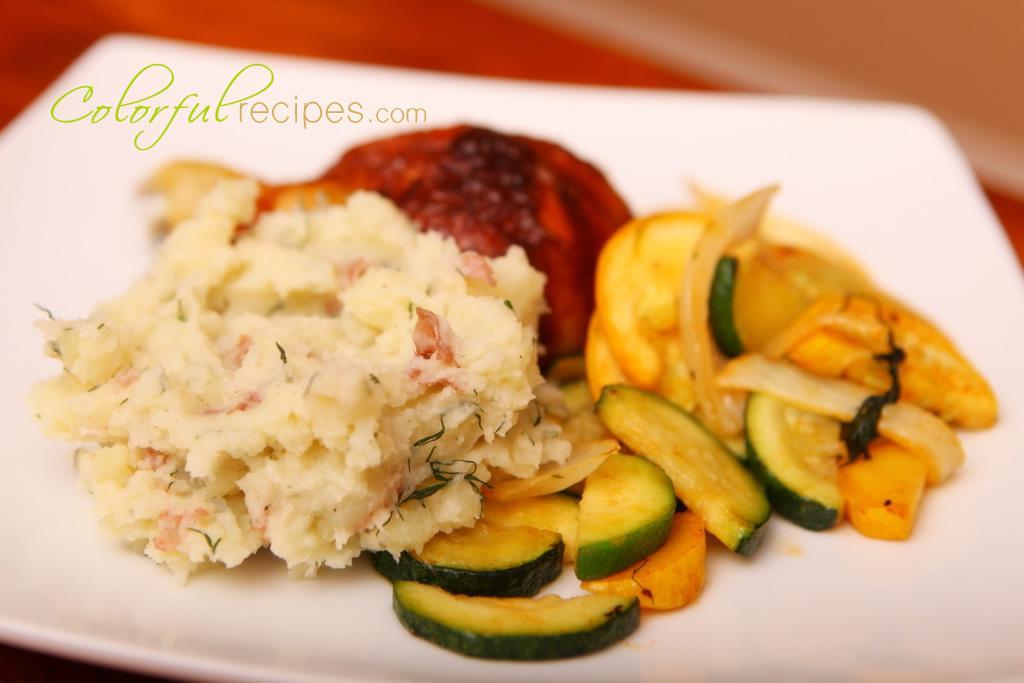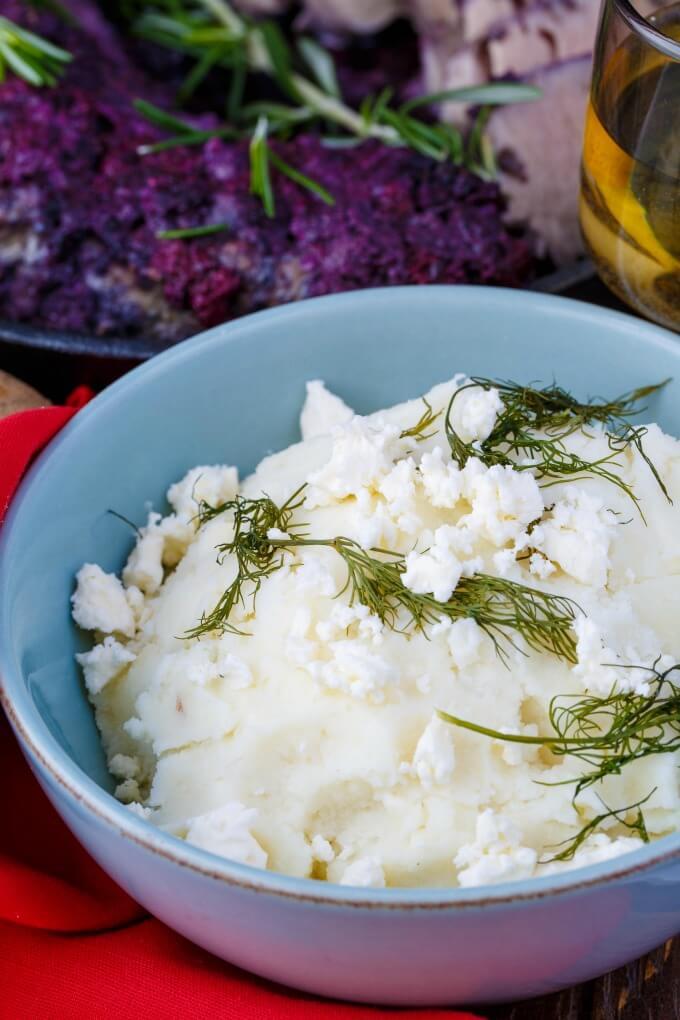The first image is the image on the left, the second image is the image on the right. Analyze the images presented: Is the assertion "In one image, mashed potatoes are served on a plate with a vegetable and a meat or fish course, while a second image shows mashed potatoes with flecks of chive." valid? Answer yes or no. Yes. The first image is the image on the left, the second image is the image on the right. Given the left and right images, does the statement "There are cut vegetables next to a mashed potato on a plate  in the left image." hold true? Answer yes or no. Yes. 